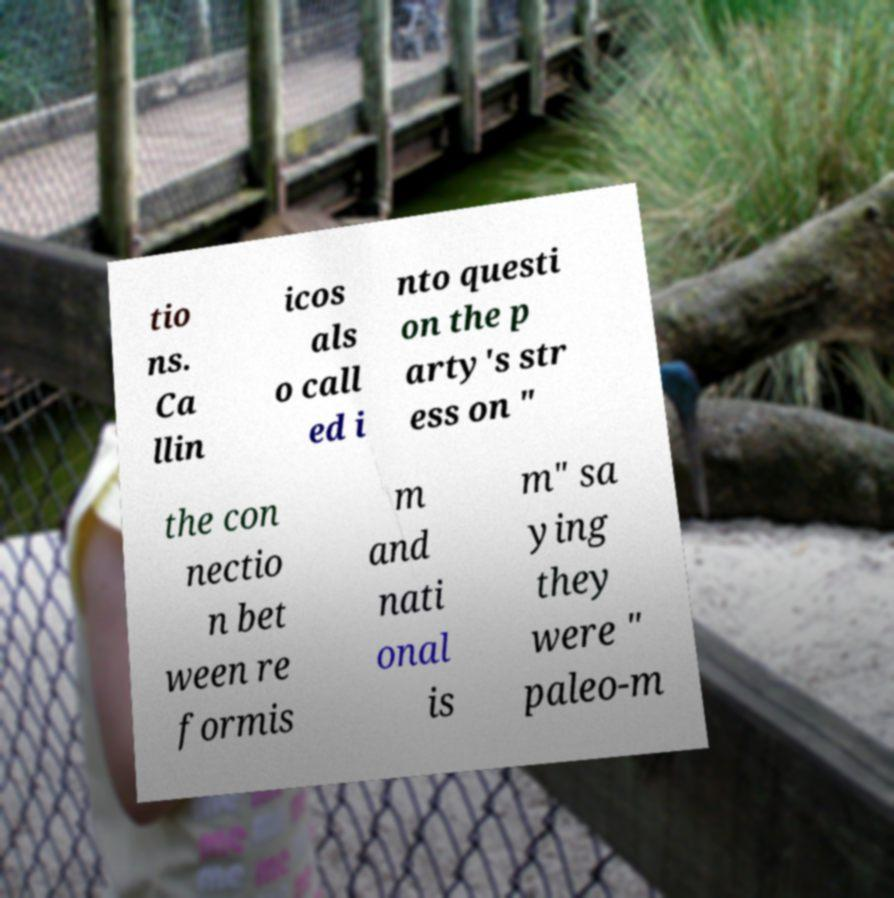What messages or text are displayed in this image? I need them in a readable, typed format. tio ns. Ca llin icos als o call ed i nto questi on the p arty's str ess on " the con nectio n bet ween re formis m and nati onal is m" sa ying they were " paleo-m 